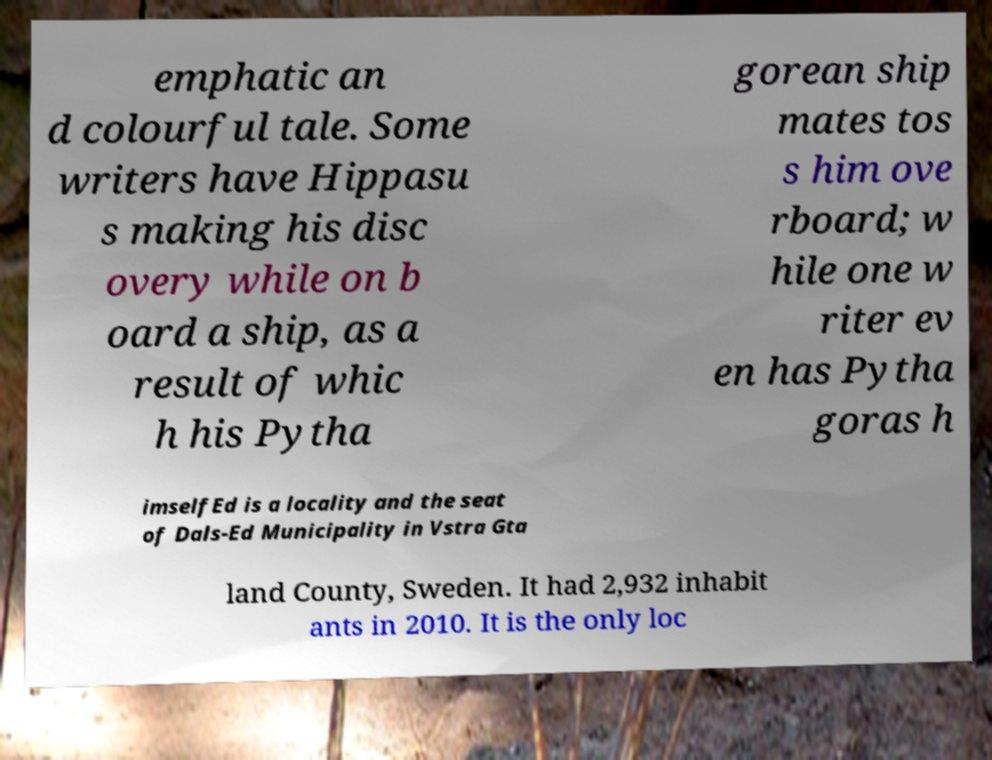There's text embedded in this image that I need extracted. Can you transcribe it verbatim? emphatic an d colourful tale. Some writers have Hippasu s making his disc overy while on b oard a ship, as a result of whic h his Pytha gorean ship mates tos s him ove rboard; w hile one w riter ev en has Pytha goras h imselfEd is a locality and the seat of Dals-Ed Municipality in Vstra Gta land County, Sweden. It had 2,932 inhabit ants in 2010. It is the only loc 